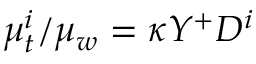Convert formula to latex. <formula><loc_0><loc_0><loc_500><loc_500>\mu _ { t } ^ { i } / \mu _ { w } = \kappa Y ^ { + } D ^ { i }</formula> 